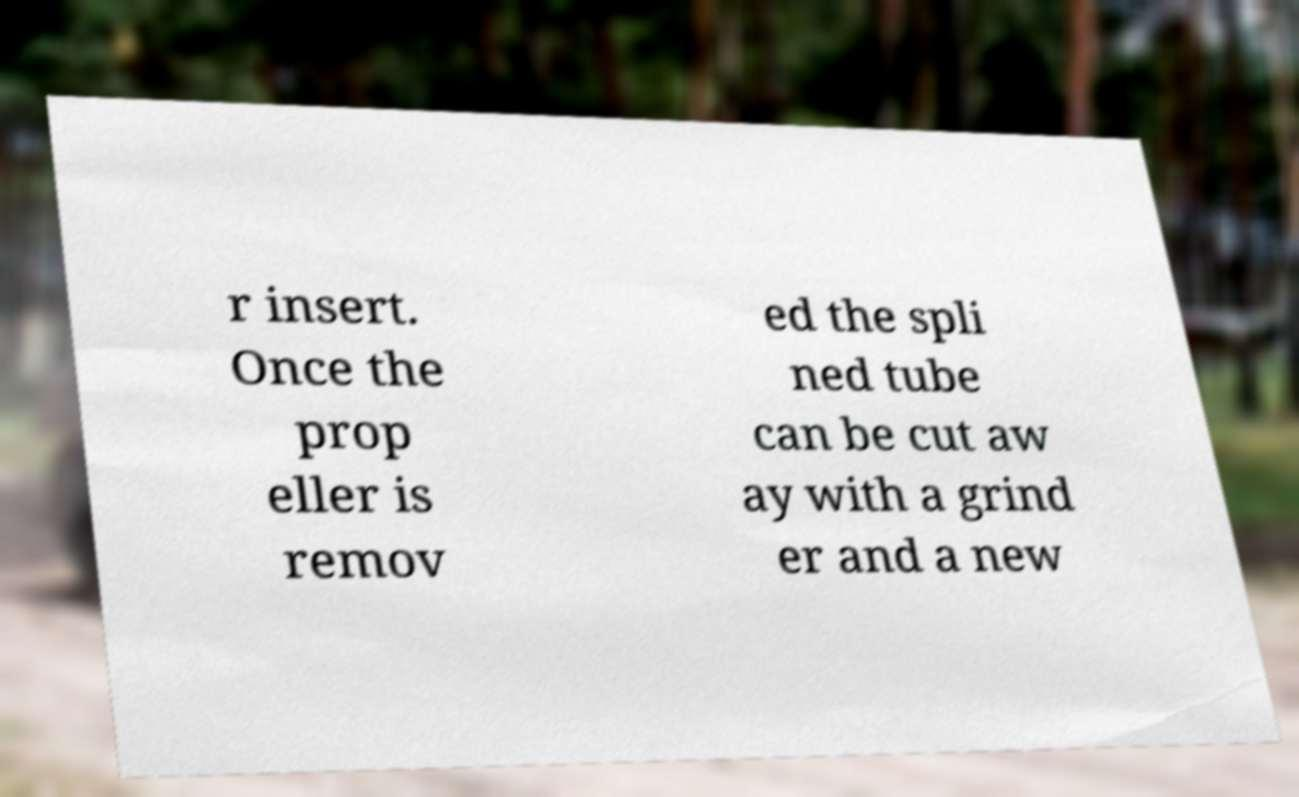Please identify and transcribe the text found in this image. r insert. Once the prop eller is remov ed the spli ned tube can be cut aw ay with a grind er and a new 